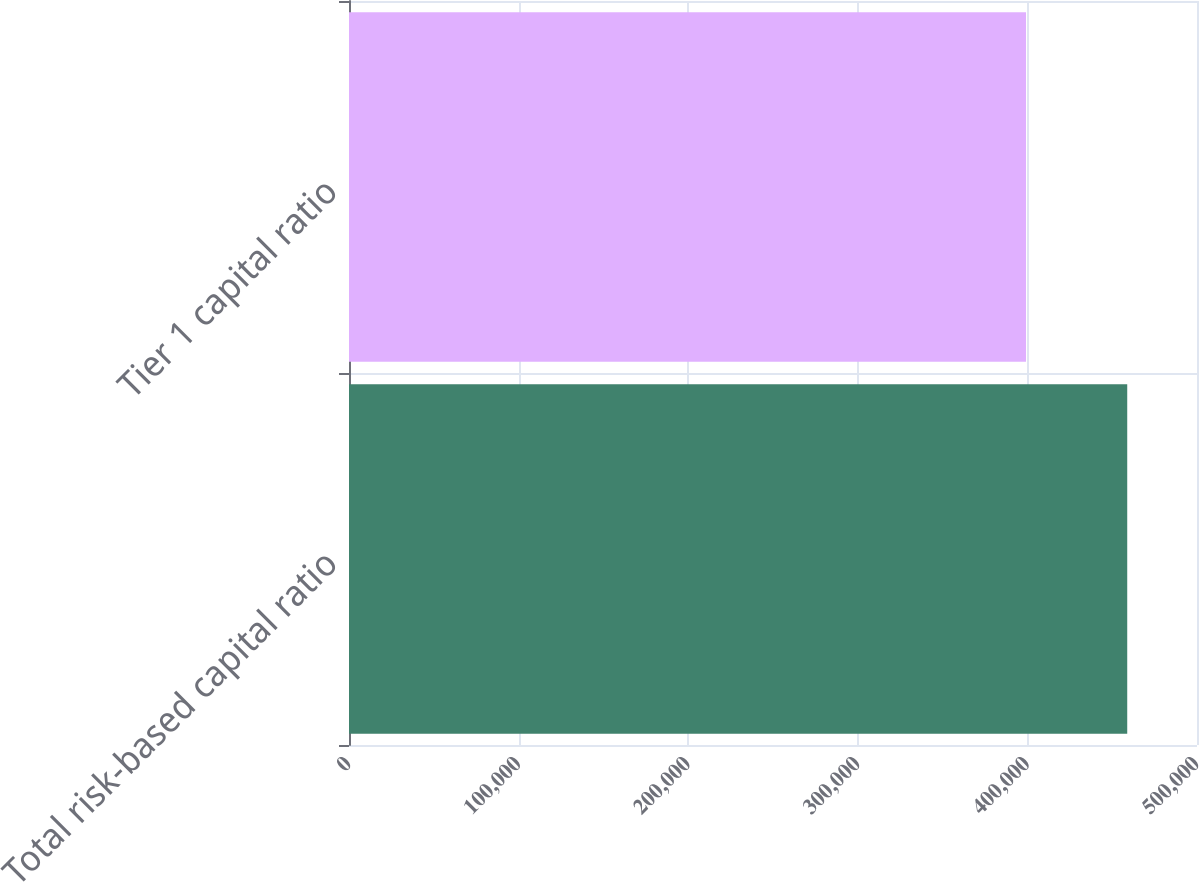<chart> <loc_0><loc_0><loc_500><loc_500><bar_chart><fcel>Total risk-based capital ratio<fcel>Tier 1 capital ratio<nl><fcel>458860<fcel>399187<nl></chart> 